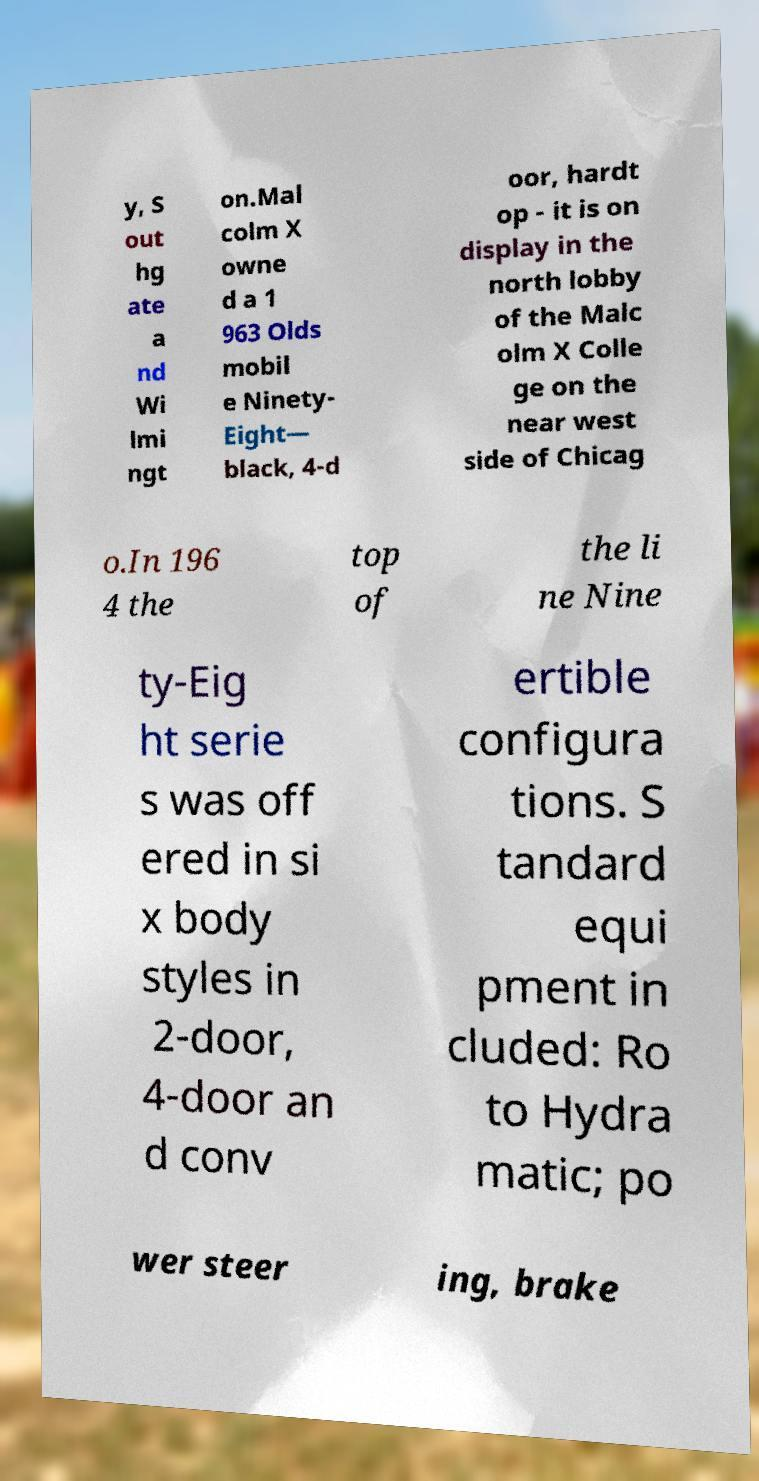Can you accurately transcribe the text from the provided image for me? y, S out hg ate a nd Wi lmi ngt on.Mal colm X owne d a 1 963 Olds mobil e Ninety- Eight— black, 4-d oor, hardt op - it is on display in the north lobby of the Malc olm X Colle ge on the near west side of Chicag o.In 196 4 the top of the li ne Nine ty-Eig ht serie s was off ered in si x body styles in 2-door, 4-door an d conv ertible configura tions. S tandard equi pment in cluded: Ro to Hydra matic; po wer steer ing, brake 